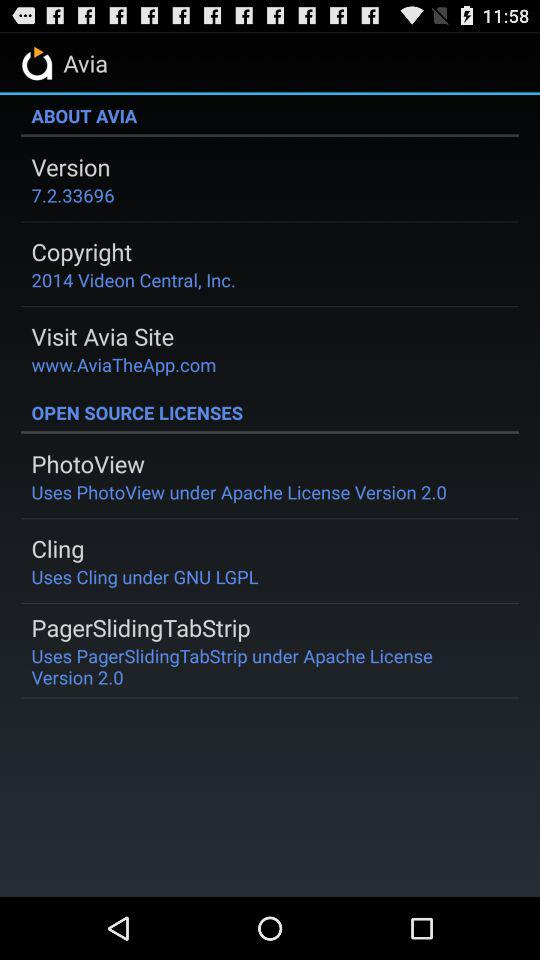What version is this? The version is 7.2.33696. 